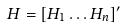Convert formula to latex. <formula><loc_0><loc_0><loc_500><loc_500>H = [ H _ { 1 } \dots H _ { n } ] ^ { \prime }</formula> 